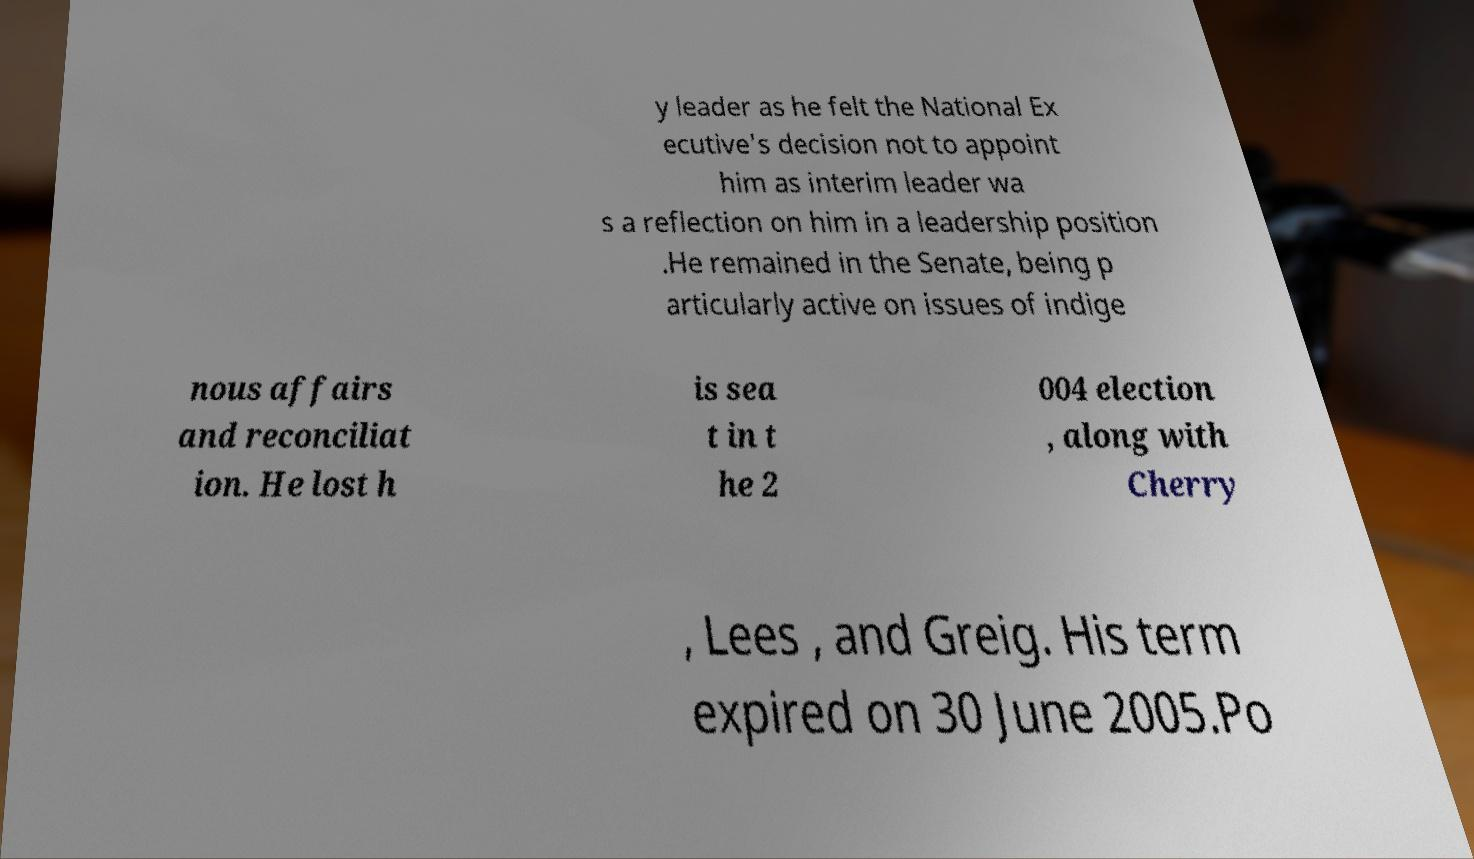Could you extract and type out the text from this image? y leader as he felt the National Ex ecutive's decision not to appoint him as interim leader wa s a reflection on him in a leadership position .He remained in the Senate, being p articularly active on issues of indige nous affairs and reconciliat ion. He lost h is sea t in t he 2 004 election , along with Cherry , Lees , and Greig. His term expired on 30 June 2005.Po 